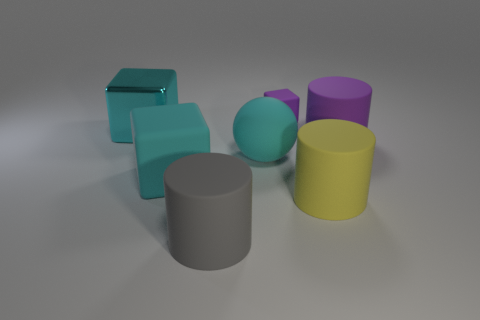Subtract all cyan cubes. How many were subtracted if there are1cyan cubes left? 1 Subtract all large cubes. How many cubes are left? 1 Subtract all purple cylinders. How many cylinders are left? 2 Subtract all balls. How many objects are left? 6 Subtract all cyan spheres. How many yellow cylinders are left? 1 Subtract all shiny blocks. Subtract all cyan matte cylinders. How many objects are left? 6 Add 1 large balls. How many large balls are left? 2 Add 3 big yellow cylinders. How many big yellow cylinders exist? 4 Add 2 brown objects. How many objects exist? 9 Subtract 0 yellow balls. How many objects are left? 7 